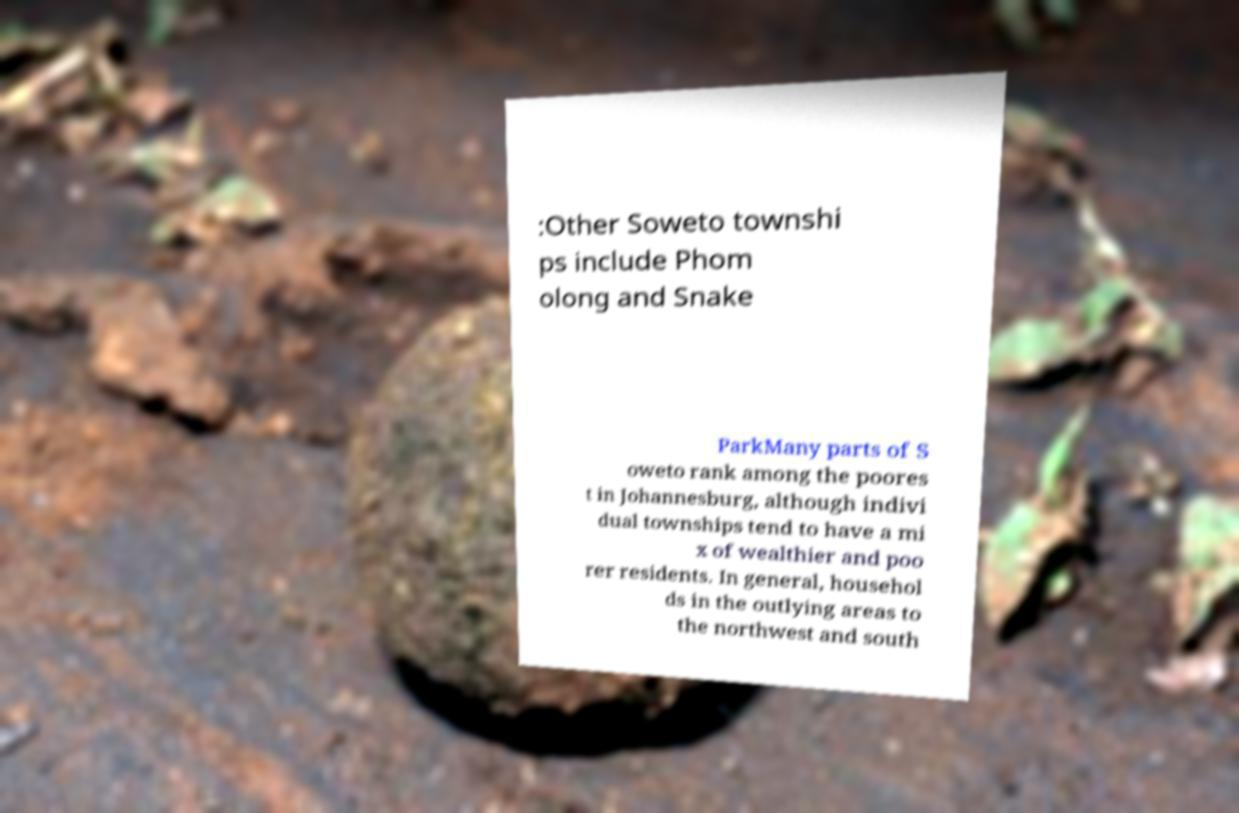Could you extract and type out the text from this image? :Other Soweto townshi ps include Phom olong and Snake ParkMany parts of S oweto rank among the poores t in Johannesburg, although indivi dual townships tend to have a mi x of wealthier and poo rer residents. In general, househol ds in the outlying areas to the northwest and south 